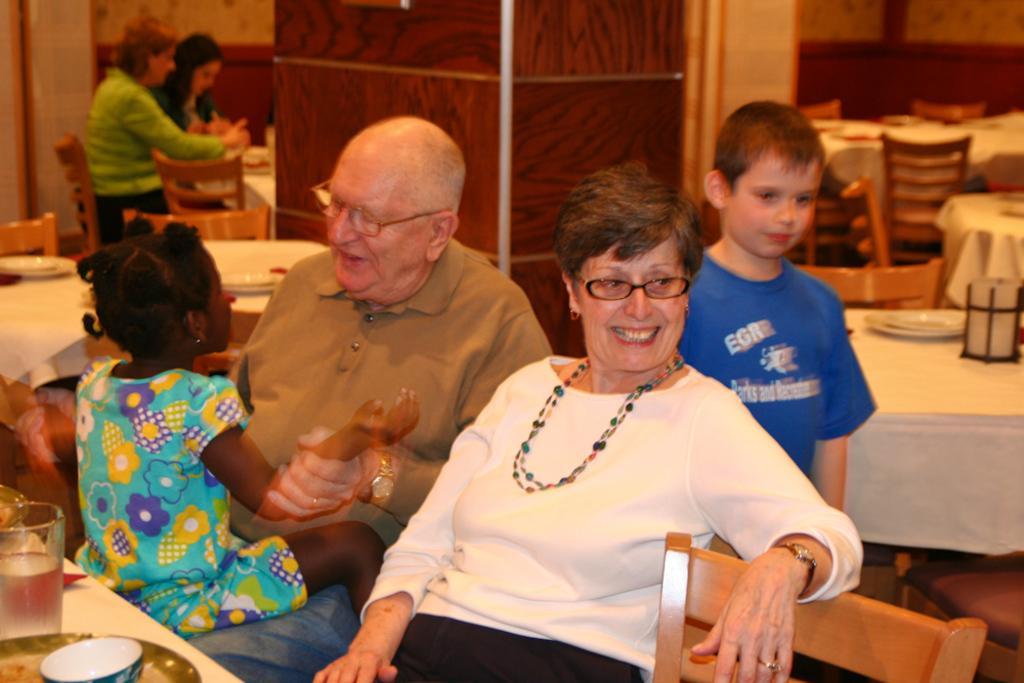Can you describe this image briefly? There is a man and woman sitting on a chair and behind her there is a there is a boy standing and a girl sitting on lap. 